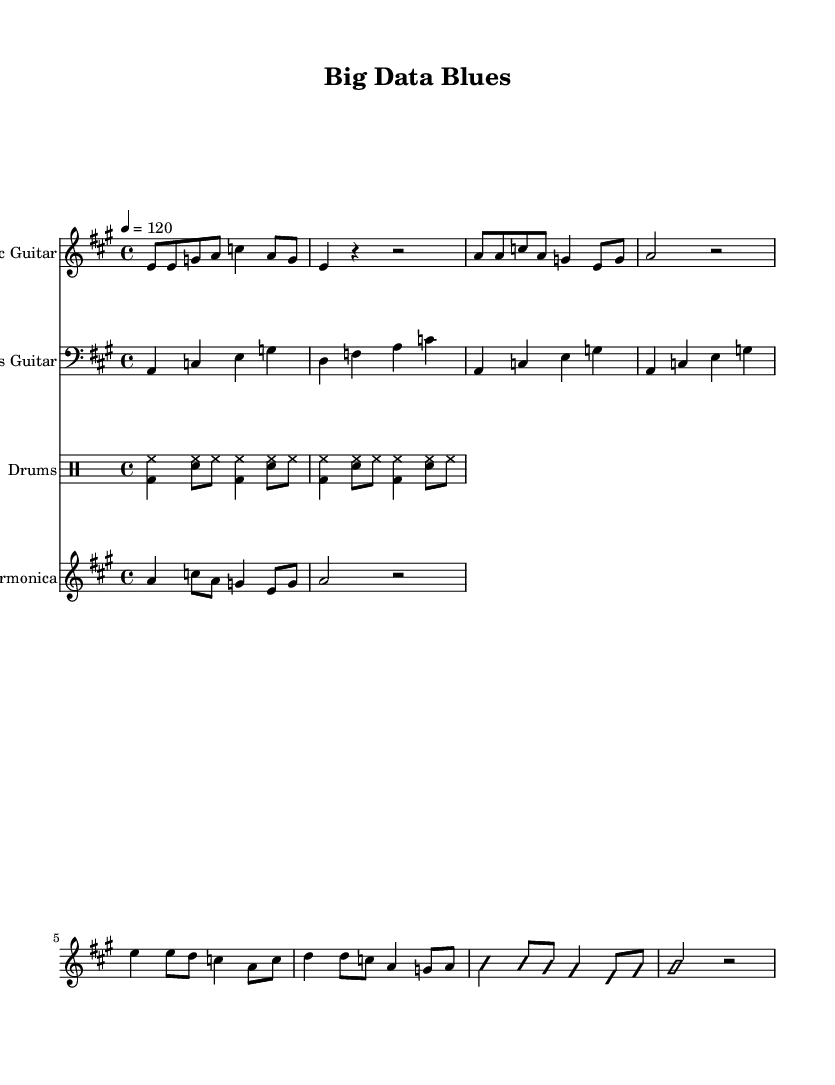What is the time signature of this composition? The time signature is indicated after the key signature at the beginning and is shown as 4/4. This means there are four beats per measure, and the quarter note receives one beat.
Answer: 4/4 What is the tempo marking of the piece? The tempo marking is provided as '4 = 120' which means the quarter note should be played at a speed of 120 beats per minute.
Answer: 120 Which instrument has the melody in the introduction? The introduction is played by the electric guitar, which is indicated first in the score with a musical staff dedicated to it and includes several notes in the opening measures.
Answer: Electric Guitar What type of bass pattern is used in this composition? The bass guitar part uses a walking bass pattern, which is characterized by a series of quarter notes that follow a chord progression in a rhythmic and melodic manner.
Answer: Walking bass What is the key signature of the music? The key signature is shown to be A major, which has three sharps (F#, C#, and G#) indicated at the beginning of the score right next to the treble clef for the electric guitar.
Answer: A major What genre does this piece exemplify? The overall feel and instrumentation, which incorporates electric guitar, bass guitar, drums, and harmonica, as well as the blues elements in the rhythms and scales, identifies this piece as a representation of Electric Blues.
Answer: Electric Blues 